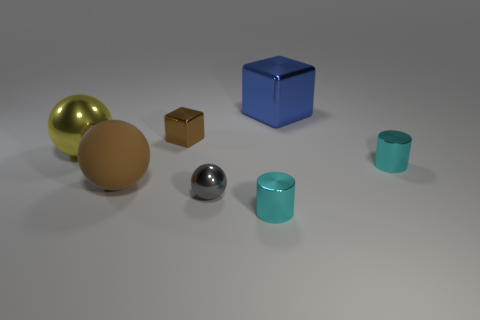How many other things are the same size as the gray sphere?
Make the answer very short. 3. Is the material of the big cube the same as the big brown object?
Keep it short and to the point. No. What color is the metal ball that is behind the small cylinder that is behind the large matte object?
Provide a short and direct response. Yellow. There is a yellow shiny thing that is the same shape as the big brown object; what is its size?
Ensure brevity in your answer.  Large. Does the matte ball have the same color as the tiny cube?
Keep it short and to the point. Yes. There is a small cyan thing that is behind the large sphere in front of the yellow metal ball; what number of metal cylinders are left of it?
Your answer should be compact. 1. Are there more large metal blocks than gray rubber cylinders?
Your answer should be very brief. Yes. What number of metallic things are there?
Offer a terse response. 6. What shape is the brown object that is in front of the big shiny object to the left of the brown thing behind the yellow metal thing?
Provide a short and direct response. Sphere. Is the number of brown blocks that are right of the tiny brown cube less than the number of yellow things that are in front of the blue metal cube?
Give a very brief answer. Yes. 